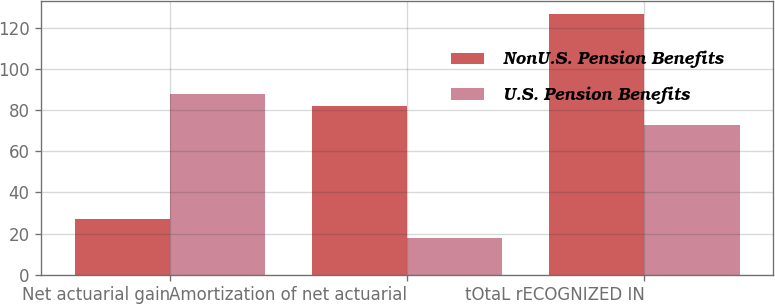<chart> <loc_0><loc_0><loc_500><loc_500><stacked_bar_chart><ecel><fcel>Net actuarial gain<fcel>Amortization of net actuarial<fcel>tOtaL rECOGNIZED IN<nl><fcel>NonU.S. Pension Benefits<fcel>27<fcel>82<fcel>127<nl><fcel>U.S. Pension Benefits<fcel>88<fcel>18<fcel>73<nl></chart> 